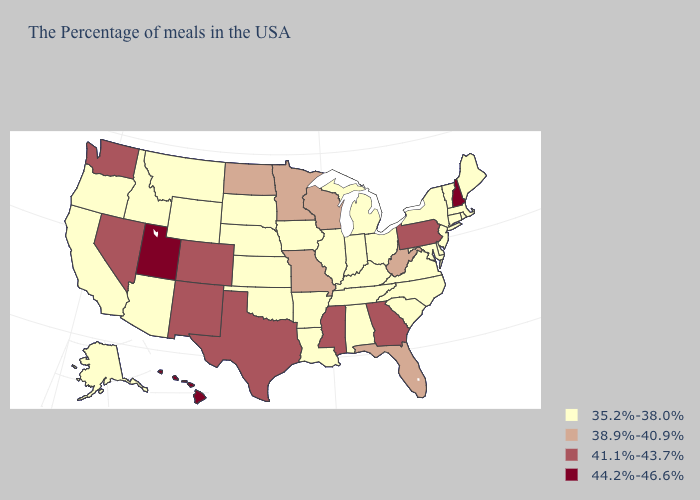Does Nevada have the lowest value in the West?
Concise answer only. No. Which states hav the highest value in the MidWest?
Give a very brief answer. Wisconsin, Missouri, Minnesota, North Dakota. What is the highest value in the South ?
Short answer required. 41.1%-43.7%. What is the value of Alabama?
Quick response, please. 35.2%-38.0%. Does Michigan have the same value as Pennsylvania?
Keep it brief. No. Name the states that have a value in the range 38.9%-40.9%?
Quick response, please. West Virginia, Florida, Wisconsin, Missouri, Minnesota, North Dakota. Name the states that have a value in the range 44.2%-46.6%?
Quick response, please. New Hampshire, Utah, Hawaii. What is the highest value in states that border Nevada?
Keep it brief. 44.2%-46.6%. What is the value of Wisconsin?
Keep it brief. 38.9%-40.9%. Is the legend a continuous bar?
Write a very short answer. No. What is the highest value in states that border South Carolina?
Answer briefly. 41.1%-43.7%. Does Utah have the highest value in the USA?
Answer briefly. Yes. How many symbols are there in the legend?
Keep it brief. 4. What is the value of Hawaii?
Concise answer only. 44.2%-46.6%. Does Indiana have a higher value than North Carolina?
Give a very brief answer. No. 